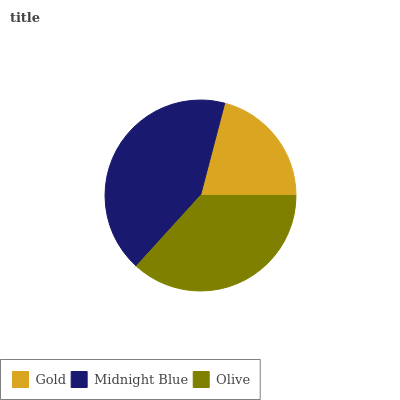Is Gold the minimum?
Answer yes or no. Yes. Is Midnight Blue the maximum?
Answer yes or no. Yes. Is Olive the minimum?
Answer yes or no. No. Is Olive the maximum?
Answer yes or no. No. Is Midnight Blue greater than Olive?
Answer yes or no. Yes. Is Olive less than Midnight Blue?
Answer yes or no. Yes. Is Olive greater than Midnight Blue?
Answer yes or no. No. Is Midnight Blue less than Olive?
Answer yes or no. No. Is Olive the high median?
Answer yes or no. Yes. Is Olive the low median?
Answer yes or no. Yes. Is Midnight Blue the high median?
Answer yes or no. No. Is Midnight Blue the low median?
Answer yes or no. No. 